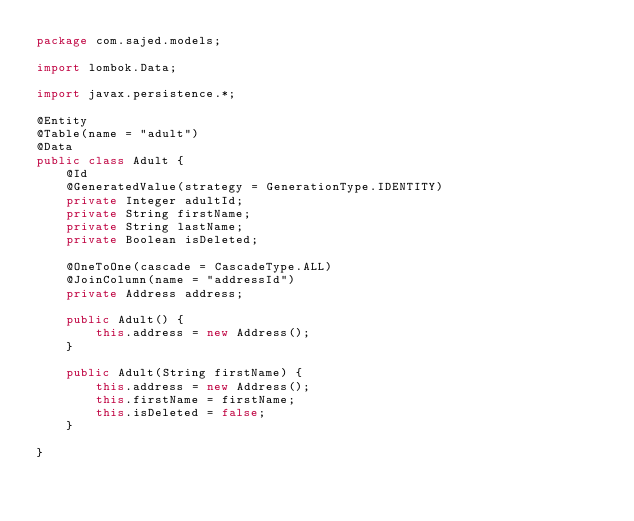Convert code to text. <code><loc_0><loc_0><loc_500><loc_500><_Java_>package com.sajed.models;

import lombok.Data;

import javax.persistence.*;

@Entity
@Table(name = "adult")
@Data
public class Adult {
    @Id
    @GeneratedValue(strategy = GenerationType.IDENTITY)
    private Integer adultId;
    private String firstName;
    private String lastName;
    private Boolean isDeleted;

    @OneToOne(cascade = CascadeType.ALL)
    @JoinColumn(name = "addressId")
    private Address address;

    public Adult() {
        this.address = new Address();
    }

    public Adult(String firstName) {
        this.address = new Address();
        this.firstName = firstName;
        this.isDeleted = false;
    }

}
</code> 